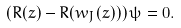<formula> <loc_0><loc_0><loc_500><loc_500>\left ( R ( z ) - R ( w _ { J } ( z ) ) \right ) \psi = 0 .</formula> 